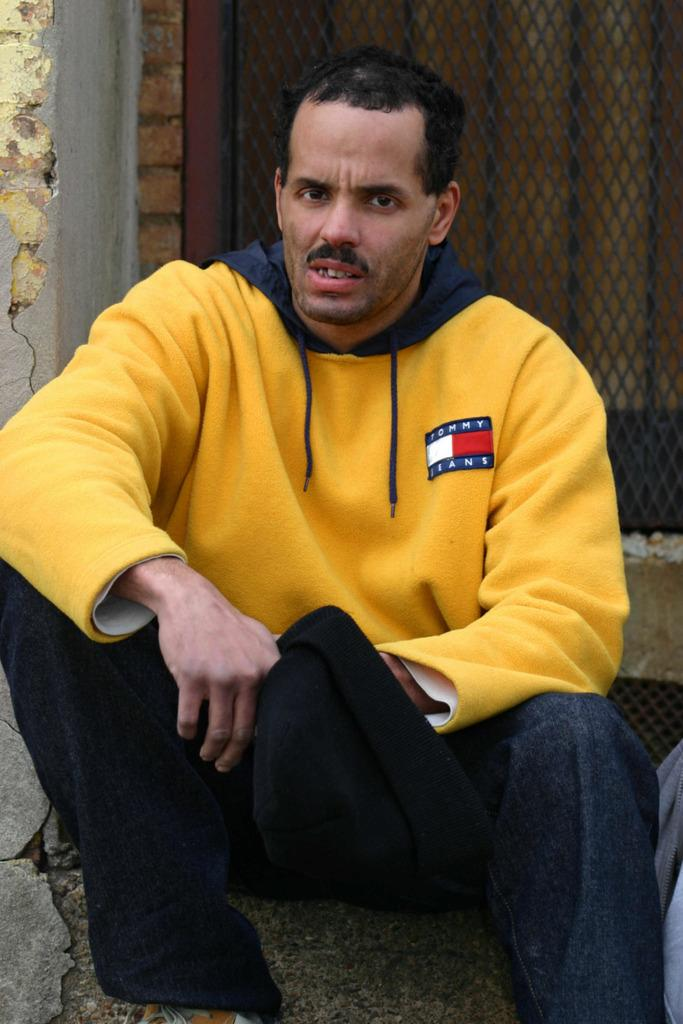<image>
Relay a brief, clear account of the picture shown. Disgusted looking man wearing a yellow Tommy Jeans hoodie. 